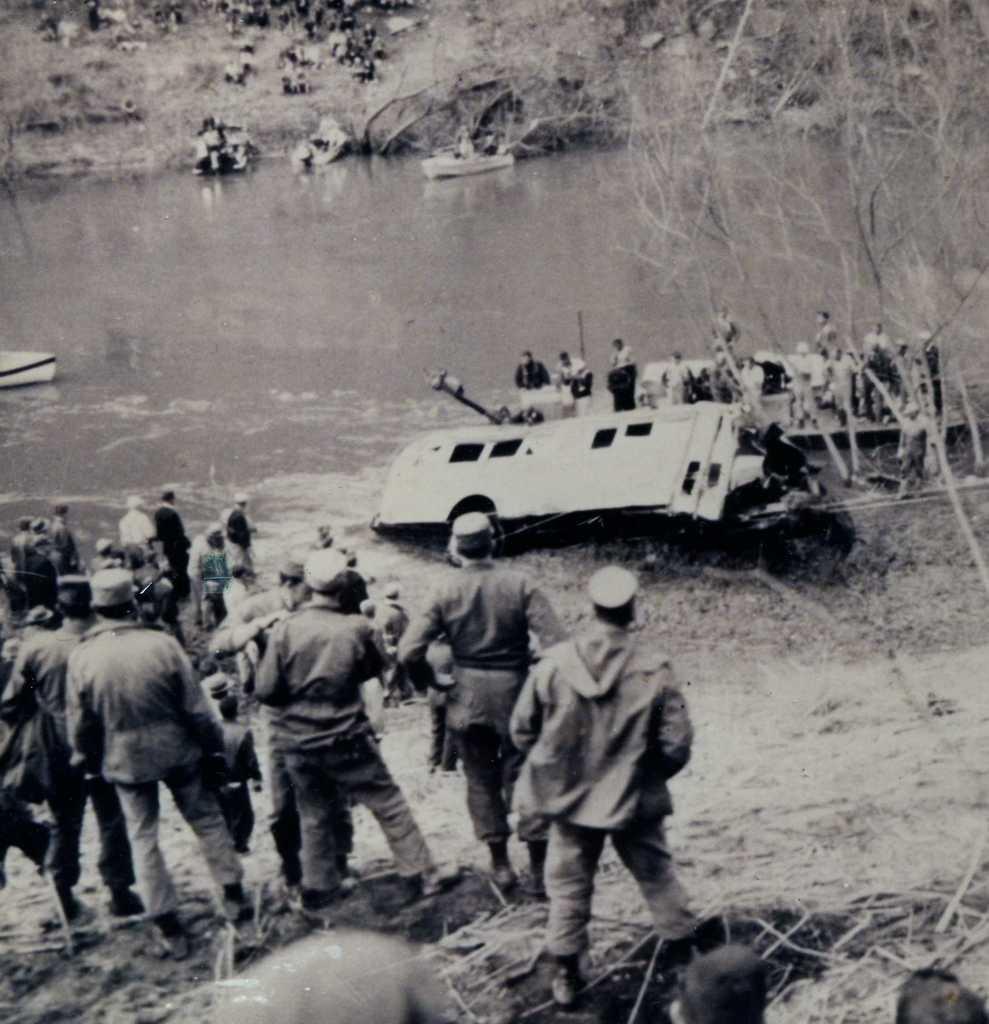Please provide a concise description of this image. This is a black and white picture. Here we can see people, groundwater, boats, trees, and other objects. 